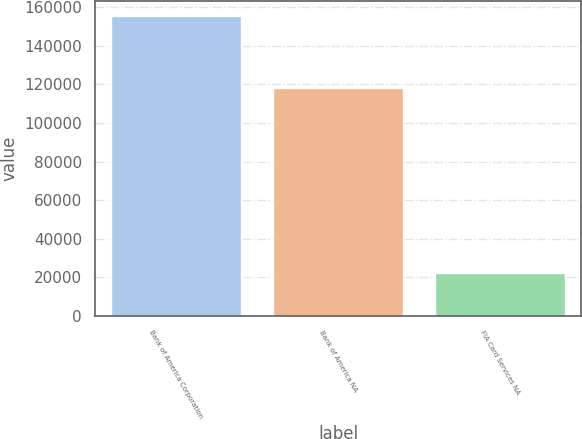<chart> <loc_0><loc_0><loc_500><loc_500><bar_chart><fcel>Bank of America Corporation<fcel>Bank of America NA<fcel>FIA Card Services NA<nl><fcel>155461<fcel>118431<fcel>22061<nl></chart> 